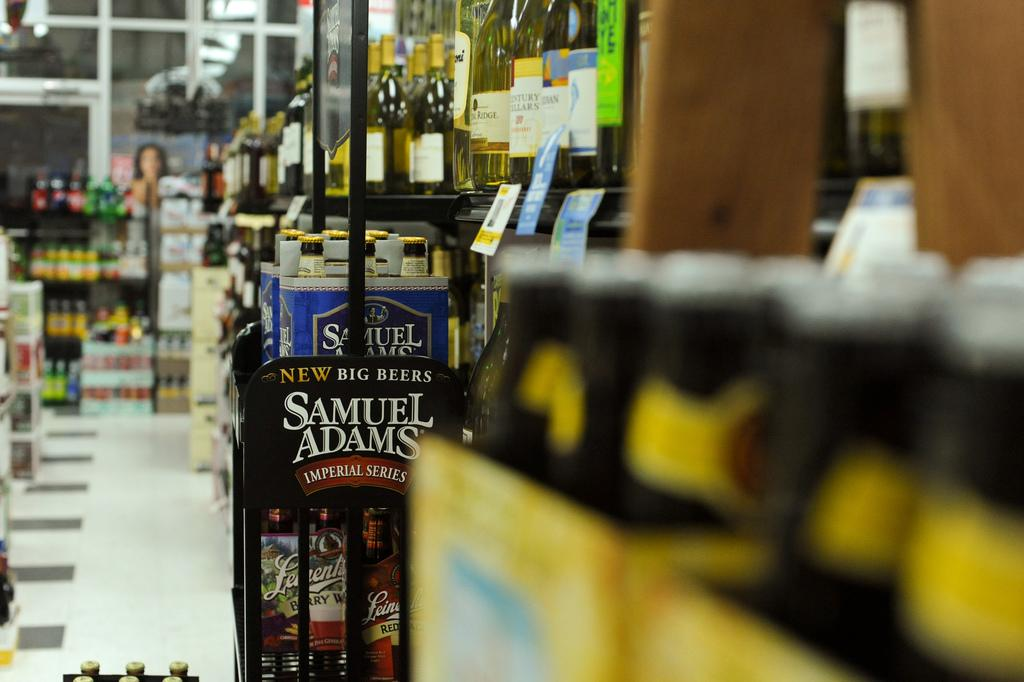What type of location is depicted in the image? The image shows the inside of a store. What can be seen on the shelves in the store? There are bottles on a rack in the store. What part of the store can be seen in the image? The floor is visible in the image. What direction are the bottles facing in the image? The provided facts do not mention the direction the bottles are facing, so it cannot be determined from the image. 